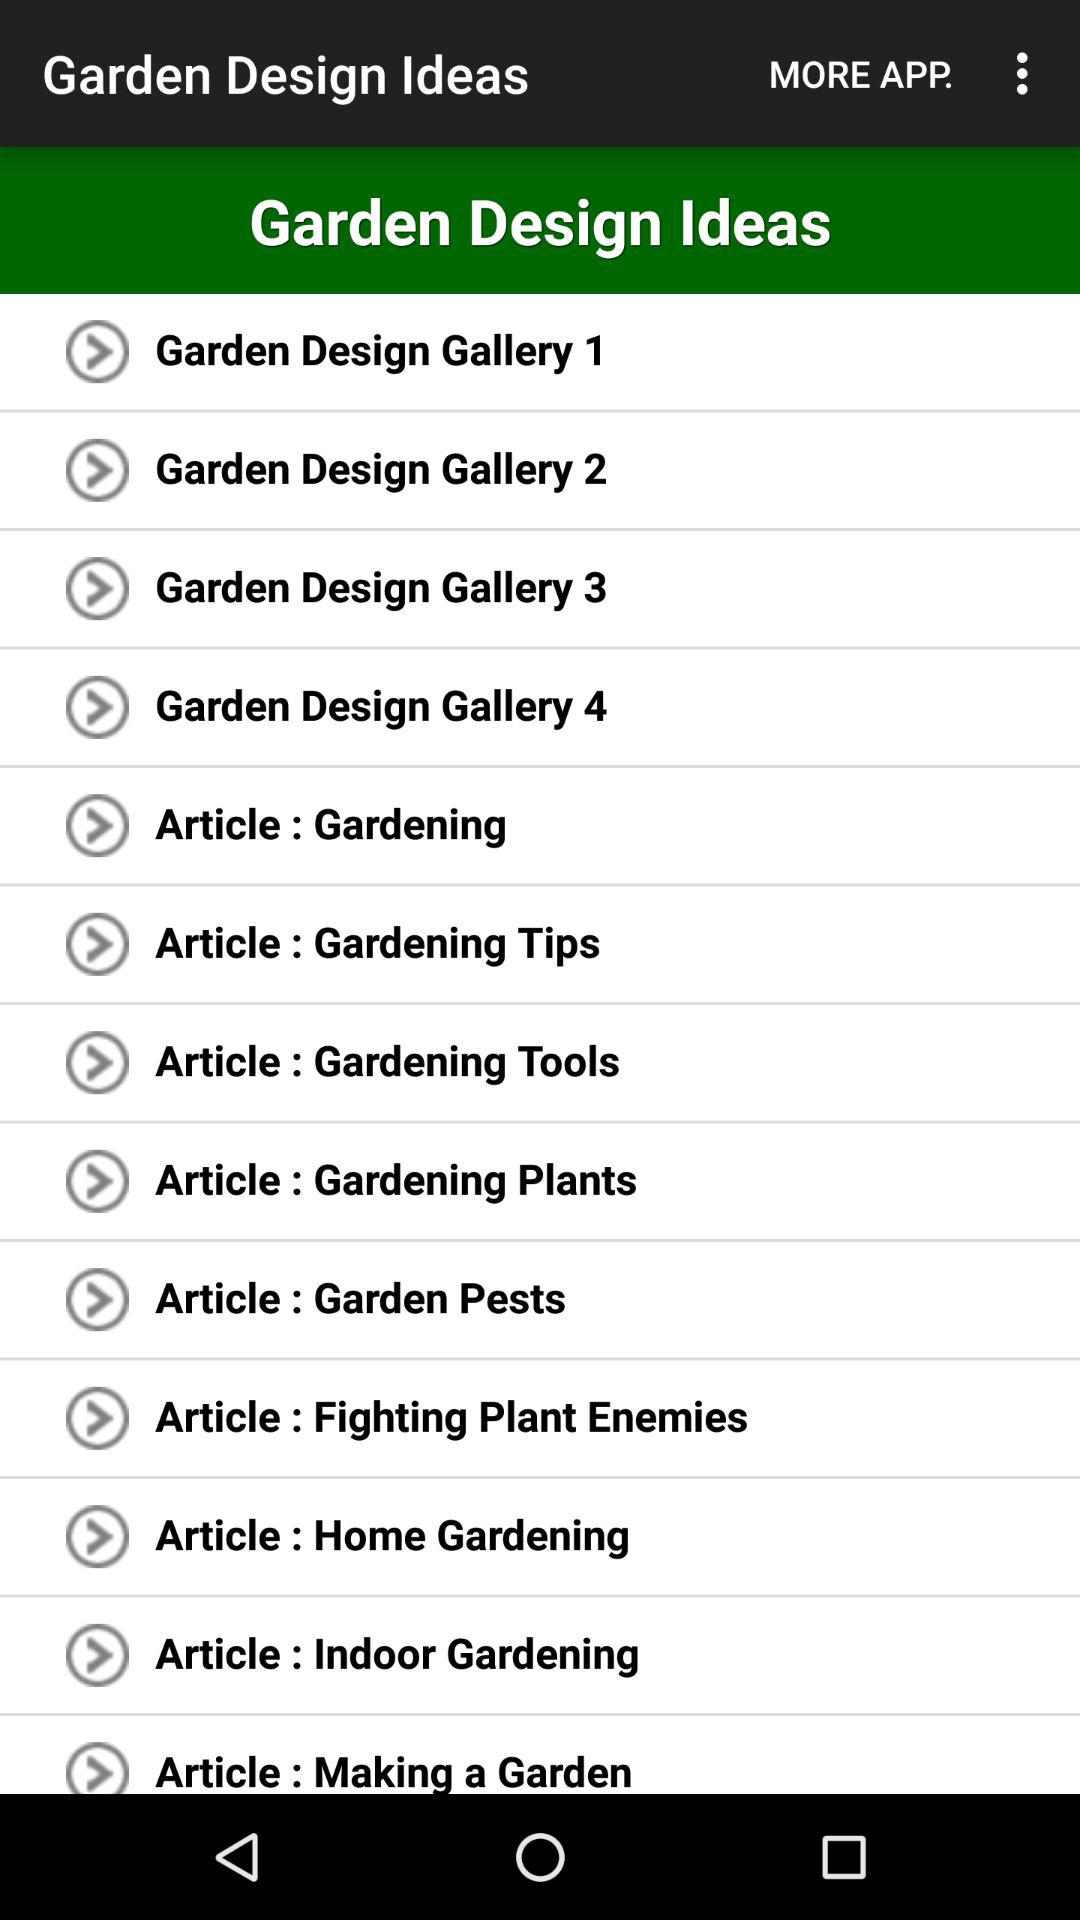How many articles are there about gardening?
Answer the question using a single word or phrase. 9 